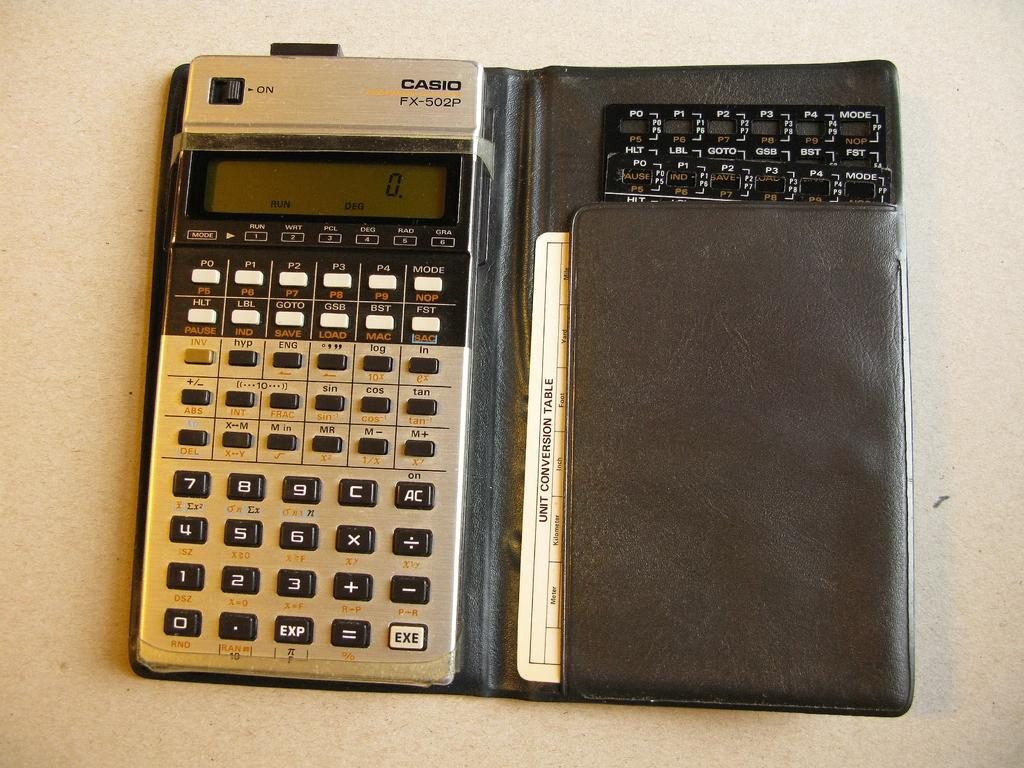<image>
Offer a succinct explanation of the picture presented. a calculator that is silver and black and labeled 'casio' on the top right 